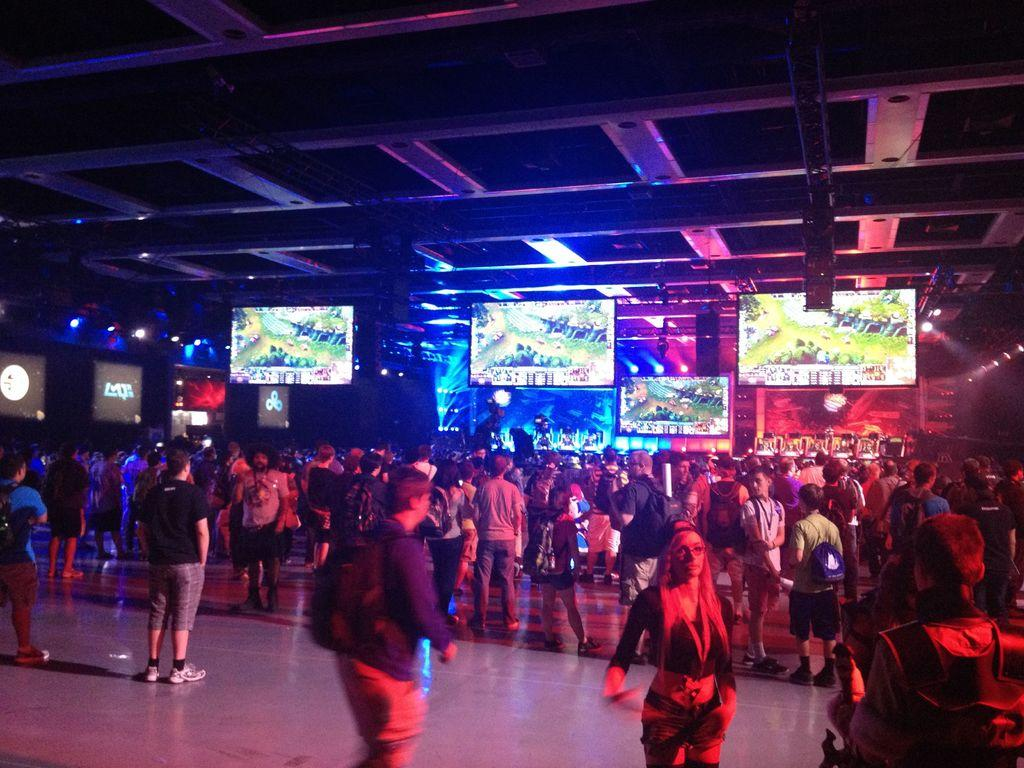How many people are in the image? There is a group of people in the image, but the exact number is not specified. Where are the people standing in the image? The people are standing on the ground in the image. What is in front of the people? There are screens and lights in front of the people, as well as some objects. What can be seen above the people in the image? There is a ceiling visible in the image. What type of coil is being used by the people in the image? There is no coil present in the image; the objects in front of the people are screens and lights. 